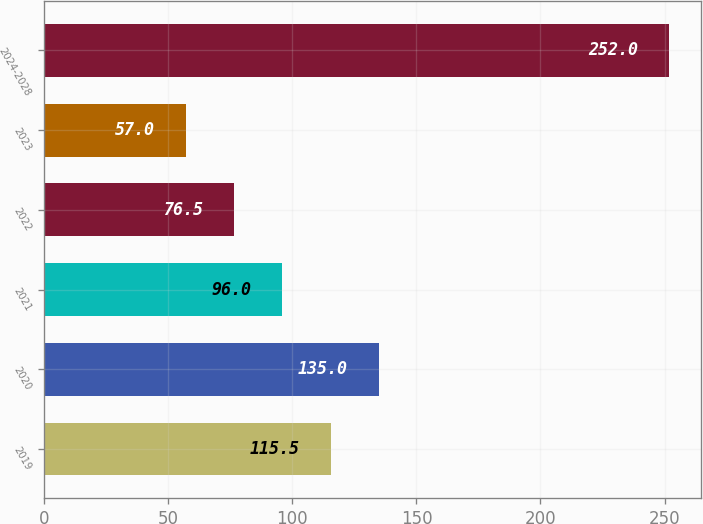<chart> <loc_0><loc_0><loc_500><loc_500><bar_chart><fcel>2019<fcel>2020<fcel>2021<fcel>2022<fcel>2023<fcel>2024-2028<nl><fcel>115.5<fcel>135<fcel>96<fcel>76.5<fcel>57<fcel>252<nl></chart> 